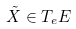<formula> <loc_0><loc_0><loc_500><loc_500>\tilde { X } \in T _ { e } E</formula> 